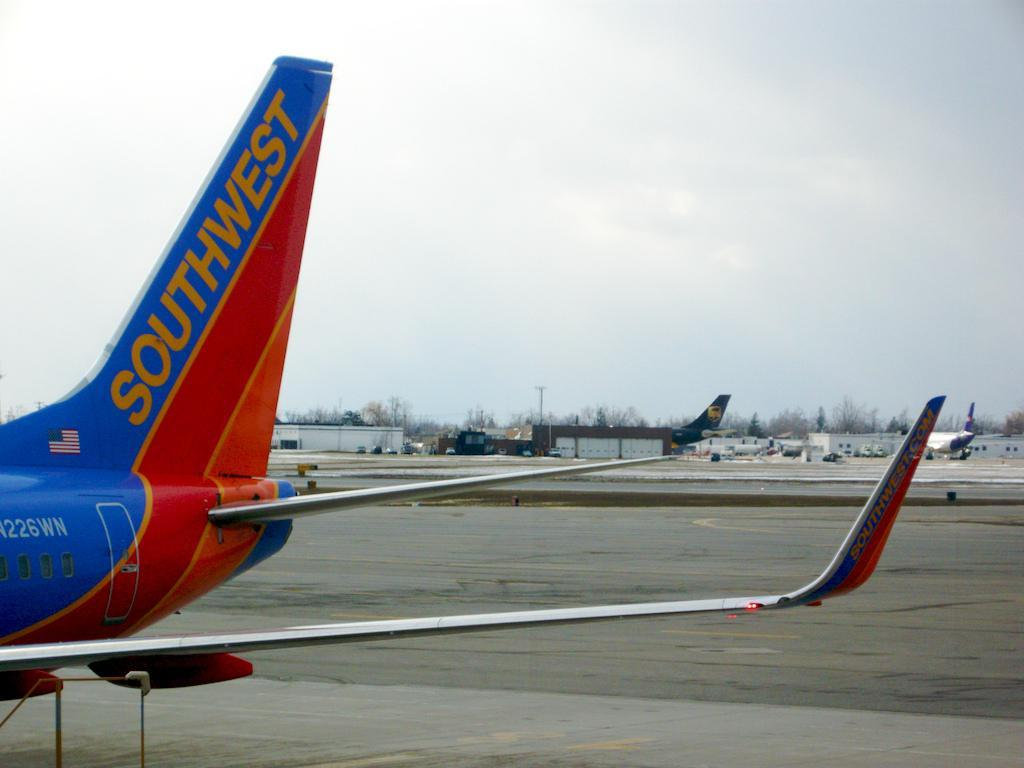<image>
Create a compact narrative representing the image presented. a southwest tail end of an airplane on the ground. 